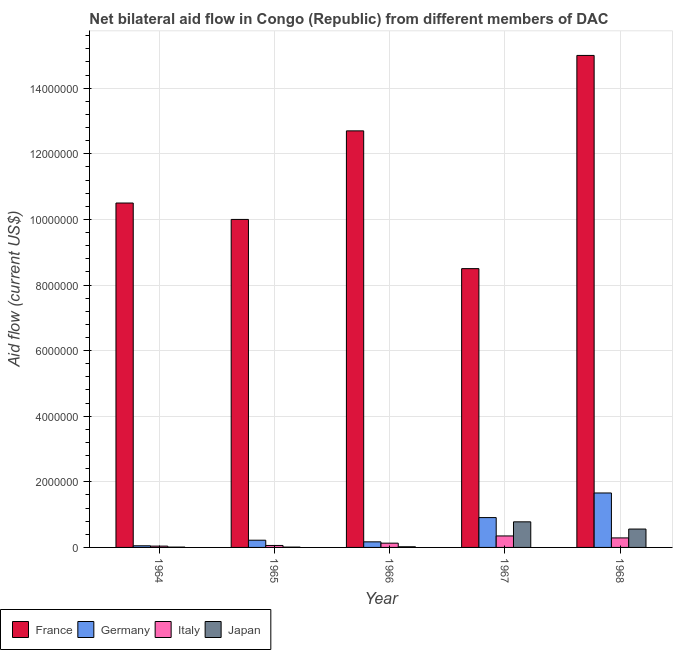How many different coloured bars are there?
Your answer should be compact. 4. Are the number of bars on each tick of the X-axis equal?
Offer a very short reply. Yes. How many bars are there on the 5th tick from the right?
Your response must be concise. 4. What is the label of the 4th group of bars from the left?
Your response must be concise. 1967. What is the amount of aid given by italy in 1965?
Your answer should be compact. 6.00e+04. Across all years, what is the maximum amount of aid given by france?
Your answer should be very brief. 1.50e+07. Across all years, what is the minimum amount of aid given by japan?
Your answer should be very brief. 10000. In which year was the amount of aid given by japan maximum?
Your answer should be compact. 1967. In which year was the amount of aid given by france minimum?
Offer a very short reply. 1967. What is the total amount of aid given by germany in the graph?
Ensure brevity in your answer.  3.01e+06. What is the difference between the amount of aid given by france in 1966 and that in 1968?
Make the answer very short. -2.30e+06. What is the difference between the amount of aid given by france in 1965 and the amount of aid given by japan in 1967?
Offer a terse response. 1.50e+06. What is the average amount of aid given by italy per year?
Provide a short and direct response. 1.74e+05. What is the ratio of the amount of aid given by japan in 1967 to that in 1968?
Your answer should be very brief. 1.39. Is the difference between the amount of aid given by japan in 1964 and 1968 greater than the difference between the amount of aid given by italy in 1964 and 1968?
Provide a short and direct response. No. What is the difference between the highest and the second highest amount of aid given by france?
Keep it short and to the point. 2.30e+06. What is the difference between the highest and the lowest amount of aid given by germany?
Provide a short and direct response. 1.61e+06. Is it the case that in every year, the sum of the amount of aid given by italy and amount of aid given by france is greater than the sum of amount of aid given by germany and amount of aid given by japan?
Provide a succinct answer. No. What does the 4th bar from the left in 1965 represents?
Give a very brief answer. Japan. What does the 3rd bar from the right in 1964 represents?
Offer a very short reply. Germany. Are all the bars in the graph horizontal?
Offer a terse response. No. How many years are there in the graph?
Your answer should be very brief. 5. Does the graph contain any zero values?
Provide a succinct answer. No. Where does the legend appear in the graph?
Provide a succinct answer. Bottom left. How many legend labels are there?
Give a very brief answer. 4. What is the title of the graph?
Your answer should be very brief. Net bilateral aid flow in Congo (Republic) from different members of DAC. What is the Aid flow (current US$) in France in 1964?
Your response must be concise. 1.05e+07. What is the Aid flow (current US$) of Germany in 1964?
Your response must be concise. 5.00e+04. What is the Aid flow (current US$) in Japan in 1964?
Offer a very short reply. 10000. What is the Aid flow (current US$) of Germany in 1965?
Ensure brevity in your answer.  2.20e+05. What is the Aid flow (current US$) of Italy in 1965?
Offer a very short reply. 6.00e+04. What is the Aid flow (current US$) in France in 1966?
Your response must be concise. 1.27e+07. What is the Aid flow (current US$) in Japan in 1966?
Ensure brevity in your answer.  2.00e+04. What is the Aid flow (current US$) of France in 1967?
Provide a succinct answer. 8.50e+06. What is the Aid flow (current US$) in Germany in 1967?
Your answer should be very brief. 9.10e+05. What is the Aid flow (current US$) of Japan in 1967?
Provide a short and direct response. 7.80e+05. What is the Aid flow (current US$) of France in 1968?
Keep it short and to the point. 1.50e+07. What is the Aid flow (current US$) in Germany in 1968?
Your answer should be compact. 1.66e+06. What is the Aid flow (current US$) in Italy in 1968?
Your response must be concise. 2.90e+05. What is the Aid flow (current US$) of Japan in 1968?
Make the answer very short. 5.60e+05. Across all years, what is the maximum Aid flow (current US$) of France?
Your answer should be very brief. 1.50e+07. Across all years, what is the maximum Aid flow (current US$) of Germany?
Offer a very short reply. 1.66e+06. Across all years, what is the maximum Aid flow (current US$) in Japan?
Ensure brevity in your answer.  7.80e+05. Across all years, what is the minimum Aid flow (current US$) in France?
Offer a terse response. 8.50e+06. Across all years, what is the minimum Aid flow (current US$) in Germany?
Provide a short and direct response. 5.00e+04. Across all years, what is the minimum Aid flow (current US$) in Italy?
Your answer should be compact. 4.00e+04. Across all years, what is the minimum Aid flow (current US$) in Japan?
Keep it short and to the point. 10000. What is the total Aid flow (current US$) of France in the graph?
Offer a very short reply. 5.67e+07. What is the total Aid flow (current US$) in Germany in the graph?
Your answer should be very brief. 3.01e+06. What is the total Aid flow (current US$) of Italy in the graph?
Offer a very short reply. 8.70e+05. What is the total Aid flow (current US$) of Japan in the graph?
Offer a very short reply. 1.38e+06. What is the difference between the Aid flow (current US$) in France in 1964 and that in 1966?
Give a very brief answer. -2.20e+06. What is the difference between the Aid flow (current US$) of Japan in 1964 and that in 1966?
Your response must be concise. -10000. What is the difference between the Aid flow (current US$) of France in 1964 and that in 1967?
Your response must be concise. 2.00e+06. What is the difference between the Aid flow (current US$) of Germany in 1964 and that in 1967?
Provide a succinct answer. -8.60e+05. What is the difference between the Aid flow (current US$) in Italy in 1964 and that in 1967?
Offer a very short reply. -3.10e+05. What is the difference between the Aid flow (current US$) of Japan in 1964 and that in 1967?
Offer a terse response. -7.70e+05. What is the difference between the Aid flow (current US$) of France in 1964 and that in 1968?
Your answer should be compact. -4.50e+06. What is the difference between the Aid flow (current US$) in Germany in 1964 and that in 1968?
Provide a short and direct response. -1.61e+06. What is the difference between the Aid flow (current US$) in Italy in 1964 and that in 1968?
Your answer should be very brief. -2.50e+05. What is the difference between the Aid flow (current US$) of Japan in 1964 and that in 1968?
Provide a short and direct response. -5.50e+05. What is the difference between the Aid flow (current US$) in France in 1965 and that in 1966?
Provide a succinct answer. -2.70e+06. What is the difference between the Aid flow (current US$) in Japan in 1965 and that in 1966?
Ensure brevity in your answer.  -10000. What is the difference between the Aid flow (current US$) in France in 1965 and that in 1967?
Offer a very short reply. 1.50e+06. What is the difference between the Aid flow (current US$) of Germany in 1965 and that in 1967?
Offer a terse response. -6.90e+05. What is the difference between the Aid flow (current US$) in Japan in 1965 and that in 1967?
Provide a succinct answer. -7.70e+05. What is the difference between the Aid flow (current US$) of France in 1965 and that in 1968?
Keep it short and to the point. -5.00e+06. What is the difference between the Aid flow (current US$) of Germany in 1965 and that in 1968?
Your response must be concise. -1.44e+06. What is the difference between the Aid flow (current US$) of Japan in 1965 and that in 1968?
Keep it short and to the point. -5.50e+05. What is the difference between the Aid flow (current US$) in France in 1966 and that in 1967?
Your answer should be compact. 4.20e+06. What is the difference between the Aid flow (current US$) in Germany in 1966 and that in 1967?
Ensure brevity in your answer.  -7.40e+05. What is the difference between the Aid flow (current US$) in Italy in 1966 and that in 1967?
Give a very brief answer. -2.20e+05. What is the difference between the Aid flow (current US$) of Japan in 1966 and that in 1967?
Your response must be concise. -7.60e+05. What is the difference between the Aid flow (current US$) in France in 1966 and that in 1968?
Offer a terse response. -2.30e+06. What is the difference between the Aid flow (current US$) of Germany in 1966 and that in 1968?
Provide a succinct answer. -1.49e+06. What is the difference between the Aid flow (current US$) of Japan in 1966 and that in 1968?
Your answer should be very brief. -5.40e+05. What is the difference between the Aid flow (current US$) in France in 1967 and that in 1968?
Offer a terse response. -6.50e+06. What is the difference between the Aid flow (current US$) in Germany in 1967 and that in 1968?
Provide a succinct answer. -7.50e+05. What is the difference between the Aid flow (current US$) in Japan in 1967 and that in 1968?
Offer a terse response. 2.20e+05. What is the difference between the Aid flow (current US$) in France in 1964 and the Aid flow (current US$) in Germany in 1965?
Offer a very short reply. 1.03e+07. What is the difference between the Aid flow (current US$) of France in 1964 and the Aid flow (current US$) of Italy in 1965?
Ensure brevity in your answer.  1.04e+07. What is the difference between the Aid flow (current US$) in France in 1964 and the Aid flow (current US$) in Japan in 1965?
Give a very brief answer. 1.05e+07. What is the difference between the Aid flow (current US$) in Germany in 1964 and the Aid flow (current US$) in Italy in 1965?
Offer a terse response. -10000. What is the difference between the Aid flow (current US$) in Germany in 1964 and the Aid flow (current US$) in Japan in 1965?
Provide a short and direct response. 4.00e+04. What is the difference between the Aid flow (current US$) in Italy in 1964 and the Aid flow (current US$) in Japan in 1965?
Give a very brief answer. 3.00e+04. What is the difference between the Aid flow (current US$) of France in 1964 and the Aid flow (current US$) of Germany in 1966?
Keep it short and to the point. 1.03e+07. What is the difference between the Aid flow (current US$) in France in 1964 and the Aid flow (current US$) in Italy in 1966?
Ensure brevity in your answer.  1.04e+07. What is the difference between the Aid flow (current US$) of France in 1964 and the Aid flow (current US$) of Japan in 1966?
Offer a very short reply. 1.05e+07. What is the difference between the Aid flow (current US$) of Germany in 1964 and the Aid flow (current US$) of Japan in 1966?
Offer a terse response. 3.00e+04. What is the difference between the Aid flow (current US$) in France in 1964 and the Aid flow (current US$) in Germany in 1967?
Give a very brief answer. 9.59e+06. What is the difference between the Aid flow (current US$) in France in 1964 and the Aid flow (current US$) in Italy in 1967?
Offer a very short reply. 1.02e+07. What is the difference between the Aid flow (current US$) of France in 1964 and the Aid flow (current US$) of Japan in 1967?
Make the answer very short. 9.72e+06. What is the difference between the Aid flow (current US$) of Germany in 1964 and the Aid flow (current US$) of Japan in 1967?
Offer a very short reply. -7.30e+05. What is the difference between the Aid flow (current US$) of Italy in 1964 and the Aid flow (current US$) of Japan in 1967?
Offer a terse response. -7.40e+05. What is the difference between the Aid flow (current US$) of France in 1964 and the Aid flow (current US$) of Germany in 1968?
Give a very brief answer. 8.84e+06. What is the difference between the Aid flow (current US$) in France in 1964 and the Aid flow (current US$) in Italy in 1968?
Your answer should be very brief. 1.02e+07. What is the difference between the Aid flow (current US$) of France in 1964 and the Aid flow (current US$) of Japan in 1968?
Provide a succinct answer. 9.94e+06. What is the difference between the Aid flow (current US$) in Germany in 1964 and the Aid flow (current US$) in Italy in 1968?
Ensure brevity in your answer.  -2.40e+05. What is the difference between the Aid flow (current US$) of Germany in 1964 and the Aid flow (current US$) of Japan in 1968?
Make the answer very short. -5.10e+05. What is the difference between the Aid flow (current US$) of Italy in 1964 and the Aid flow (current US$) of Japan in 1968?
Your answer should be very brief. -5.20e+05. What is the difference between the Aid flow (current US$) of France in 1965 and the Aid flow (current US$) of Germany in 1966?
Provide a short and direct response. 9.83e+06. What is the difference between the Aid flow (current US$) in France in 1965 and the Aid flow (current US$) in Italy in 1966?
Offer a very short reply. 9.87e+06. What is the difference between the Aid flow (current US$) of France in 1965 and the Aid flow (current US$) of Japan in 1966?
Keep it short and to the point. 9.98e+06. What is the difference between the Aid flow (current US$) in Germany in 1965 and the Aid flow (current US$) in Japan in 1966?
Provide a succinct answer. 2.00e+05. What is the difference between the Aid flow (current US$) in Italy in 1965 and the Aid flow (current US$) in Japan in 1966?
Ensure brevity in your answer.  4.00e+04. What is the difference between the Aid flow (current US$) in France in 1965 and the Aid flow (current US$) in Germany in 1967?
Give a very brief answer. 9.09e+06. What is the difference between the Aid flow (current US$) in France in 1965 and the Aid flow (current US$) in Italy in 1967?
Offer a very short reply. 9.65e+06. What is the difference between the Aid flow (current US$) in France in 1965 and the Aid flow (current US$) in Japan in 1967?
Offer a very short reply. 9.22e+06. What is the difference between the Aid flow (current US$) of Germany in 1965 and the Aid flow (current US$) of Italy in 1967?
Offer a terse response. -1.30e+05. What is the difference between the Aid flow (current US$) of Germany in 1965 and the Aid flow (current US$) of Japan in 1967?
Your response must be concise. -5.60e+05. What is the difference between the Aid flow (current US$) in Italy in 1965 and the Aid flow (current US$) in Japan in 1967?
Give a very brief answer. -7.20e+05. What is the difference between the Aid flow (current US$) of France in 1965 and the Aid flow (current US$) of Germany in 1968?
Offer a very short reply. 8.34e+06. What is the difference between the Aid flow (current US$) in France in 1965 and the Aid flow (current US$) in Italy in 1968?
Provide a succinct answer. 9.71e+06. What is the difference between the Aid flow (current US$) of France in 1965 and the Aid flow (current US$) of Japan in 1968?
Ensure brevity in your answer.  9.44e+06. What is the difference between the Aid flow (current US$) in Germany in 1965 and the Aid flow (current US$) in Italy in 1968?
Provide a succinct answer. -7.00e+04. What is the difference between the Aid flow (current US$) in Germany in 1965 and the Aid flow (current US$) in Japan in 1968?
Your response must be concise. -3.40e+05. What is the difference between the Aid flow (current US$) in Italy in 1965 and the Aid flow (current US$) in Japan in 1968?
Ensure brevity in your answer.  -5.00e+05. What is the difference between the Aid flow (current US$) in France in 1966 and the Aid flow (current US$) in Germany in 1967?
Your answer should be very brief. 1.18e+07. What is the difference between the Aid flow (current US$) in France in 1966 and the Aid flow (current US$) in Italy in 1967?
Your answer should be compact. 1.24e+07. What is the difference between the Aid flow (current US$) in France in 1966 and the Aid flow (current US$) in Japan in 1967?
Your answer should be very brief. 1.19e+07. What is the difference between the Aid flow (current US$) of Germany in 1966 and the Aid flow (current US$) of Japan in 1967?
Make the answer very short. -6.10e+05. What is the difference between the Aid flow (current US$) in Italy in 1966 and the Aid flow (current US$) in Japan in 1967?
Your answer should be very brief. -6.50e+05. What is the difference between the Aid flow (current US$) in France in 1966 and the Aid flow (current US$) in Germany in 1968?
Offer a terse response. 1.10e+07. What is the difference between the Aid flow (current US$) of France in 1966 and the Aid flow (current US$) of Italy in 1968?
Your answer should be compact. 1.24e+07. What is the difference between the Aid flow (current US$) of France in 1966 and the Aid flow (current US$) of Japan in 1968?
Make the answer very short. 1.21e+07. What is the difference between the Aid flow (current US$) in Germany in 1966 and the Aid flow (current US$) in Italy in 1968?
Provide a succinct answer. -1.20e+05. What is the difference between the Aid flow (current US$) of Germany in 1966 and the Aid flow (current US$) of Japan in 1968?
Keep it short and to the point. -3.90e+05. What is the difference between the Aid flow (current US$) of Italy in 1966 and the Aid flow (current US$) of Japan in 1968?
Offer a very short reply. -4.30e+05. What is the difference between the Aid flow (current US$) in France in 1967 and the Aid flow (current US$) in Germany in 1968?
Provide a short and direct response. 6.84e+06. What is the difference between the Aid flow (current US$) of France in 1967 and the Aid flow (current US$) of Italy in 1968?
Your answer should be compact. 8.21e+06. What is the difference between the Aid flow (current US$) of France in 1967 and the Aid flow (current US$) of Japan in 1968?
Your answer should be very brief. 7.94e+06. What is the difference between the Aid flow (current US$) in Germany in 1967 and the Aid flow (current US$) in Italy in 1968?
Give a very brief answer. 6.20e+05. What is the average Aid flow (current US$) of France per year?
Your answer should be compact. 1.13e+07. What is the average Aid flow (current US$) of Germany per year?
Your answer should be compact. 6.02e+05. What is the average Aid flow (current US$) in Italy per year?
Make the answer very short. 1.74e+05. What is the average Aid flow (current US$) in Japan per year?
Provide a succinct answer. 2.76e+05. In the year 1964, what is the difference between the Aid flow (current US$) in France and Aid flow (current US$) in Germany?
Ensure brevity in your answer.  1.04e+07. In the year 1964, what is the difference between the Aid flow (current US$) of France and Aid flow (current US$) of Italy?
Keep it short and to the point. 1.05e+07. In the year 1964, what is the difference between the Aid flow (current US$) in France and Aid flow (current US$) in Japan?
Offer a very short reply. 1.05e+07. In the year 1965, what is the difference between the Aid flow (current US$) in France and Aid flow (current US$) in Germany?
Keep it short and to the point. 9.78e+06. In the year 1965, what is the difference between the Aid flow (current US$) of France and Aid flow (current US$) of Italy?
Your response must be concise. 9.94e+06. In the year 1965, what is the difference between the Aid flow (current US$) in France and Aid flow (current US$) in Japan?
Give a very brief answer. 9.99e+06. In the year 1966, what is the difference between the Aid flow (current US$) in France and Aid flow (current US$) in Germany?
Offer a very short reply. 1.25e+07. In the year 1966, what is the difference between the Aid flow (current US$) of France and Aid flow (current US$) of Italy?
Provide a succinct answer. 1.26e+07. In the year 1966, what is the difference between the Aid flow (current US$) in France and Aid flow (current US$) in Japan?
Give a very brief answer. 1.27e+07. In the year 1966, what is the difference between the Aid flow (current US$) of Germany and Aid flow (current US$) of Japan?
Your answer should be compact. 1.50e+05. In the year 1967, what is the difference between the Aid flow (current US$) of France and Aid flow (current US$) of Germany?
Make the answer very short. 7.59e+06. In the year 1967, what is the difference between the Aid flow (current US$) in France and Aid flow (current US$) in Italy?
Provide a short and direct response. 8.15e+06. In the year 1967, what is the difference between the Aid flow (current US$) of France and Aid flow (current US$) of Japan?
Provide a short and direct response. 7.72e+06. In the year 1967, what is the difference between the Aid flow (current US$) of Germany and Aid flow (current US$) of Italy?
Provide a short and direct response. 5.60e+05. In the year 1967, what is the difference between the Aid flow (current US$) of Germany and Aid flow (current US$) of Japan?
Your answer should be compact. 1.30e+05. In the year 1967, what is the difference between the Aid flow (current US$) of Italy and Aid flow (current US$) of Japan?
Your answer should be compact. -4.30e+05. In the year 1968, what is the difference between the Aid flow (current US$) in France and Aid flow (current US$) in Germany?
Offer a very short reply. 1.33e+07. In the year 1968, what is the difference between the Aid flow (current US$) in France and Aid flow (current US$) in Italy?
Your answer should be very brief. 1.47e+07. In the year 1968, what is the difference between the Aid flow (current US$) in France and Aid flow (current US$) in Japan?
Your answer should be very brief. 1.44e+07. In the year 1968, what is the difference between the Aid flow (current US$) in Germany and Aid flow (current US$) in Italy?
Ensure brevity in your answer.  1.37e+06. In the year 1968, what is the difference between the Aid flow (current US$) of Germany and Aid flow (current US$) of Japan?
Give a very brief answer. 1.10e+06. In the year 1968, what is the difference between the Aid flow (current US$) of Italy and Aid flow (current US$) of Japan?
Your answer should be very brief. -2.70e+05. What is the ratio of the Aid flow (current US$) in France in 1964 to that in 1965?
Offer a terse response. 1.05. What is the ratio of the Aid flow (current US$) in Germany in 1964 to that in 1965?
Ensure brevity in your answer.  0.23. What is the ratio of the Aid flow (current US$) in Italy in 1964 to that in 1965?
Provide a short and direct response. 0.67. What is the ratio of the Aid flow (current US$) in France in 1964 to that in 1966?
Make the answer very short. 0.83. What is the ratio of the Aid flow (current US$) of Germany in 1964 to that in 1966?
Provide a succinct answer. 0.29. What is the ratio of the Aid flow (current US$) in Italy in 1964 to that in 1966?
Keep it short and to the point. 0.31. What is the ratio of the Aid flow (current US$) in France in 1964 to that in 1967?
Make the answer very short. 1.24. What is the ratio of the Aid flow (current US$) of Germany in 1964 to that in 1967?
Your answer should be very brief. 0.05. What is the ratio of the Aid flow (current US$) of Italy in 1964 to that in 1967?
Your answer should be compact. 0.11. What is the ratio of the Aid flow (current US$) of Japan in 1964 to that in 1967?
Give a very brief answer. 0.01. What is the ratio of the Aid flow (current US$) of Germany in 1964 to that in 1968?
Ensure brevity in your answer.  0.03. What is the ratio of the Aid flow (current US$) in Italy in 1964 to that in 1968?
Provide a short and direct response. 0.14. What is the ratio of the Aid flow (current US$) of Japan in 1964 to that in 1968?
Keep it short and to the point. 0.02. What is the ratio of the Aid flow (current US$) in France in 1965 to that in 1966?
Offer a terse response. 0.79. What is the ratio of the Aid flow (current US$) of Germany in 1965 to that in 1966?
Provide a short and direct response. 1.29. What is the ratio of the Aid flow (current US$) of Italy in 1965 to that in 1966?
Your response must be concise. 0.46. What is the ratio of the Aid flow (current US$) in France in 1965 to that in 1967?
Your answer should be very brief. 1.18. What is the ratio of the Aid flow (current US$) of Germany in 1965 to that in 1967?
Your answer should be very brief. 0.24. What is the ratio of the Aid flow (current US$) in Italy in 1965 to that in 1967?
Keep it short and to the point. 0.17. What is the ratio of the Aid flow (current US$) of Japan in 1965 to that in 1967?
Keep it short and to the point. 0.01. What is the ratio of the Aid flow (current US$) of France in 1965 to that in 1968?
Make the answer very short. 0.67. What is the ratio of the Aid flow (current US$) in Germany in 1965 to that in 1968?
Your answer should be compact. 0.13. What is the ratio of the Aid flow (current US$) in Italy in 1965 to that in 1968?
Offer a terse response. 0.21. What is the ratio of the Aid flow (current US$) in Japan in 1965 to that in 1968?
Provide a short and direct response. 0.02. What is the ratio of the Aid flow (current US$) of France in 1966 to that in 1967?
Provide a short and direct response. 1.49. What is the ratio of the Aid flow (current US$) in Germany in 1966 to that in 1967?
Give a very brief answer. 0.19. What is the ratio of the Aid flow (current US$) in Italy in 1966 to that in 1967?
Your response must be concise. 0.37. What is the ratio of the Aid flow (current US$) of Japan in 1966 to that in 1967?
Make the answer very short. 0.03. What is the ratio of the Aid flow (current US$) of France in 1966 to that in 1968?
Ensure brevity in your answer.  0.85. What is the ratio of the Aid flow (current US$) in Germany in 1966 to that in 1968?
Provide a succinct answer. 0.1. What is the ratio of the Aid flow (current US$) of Italy in 1966 to that in 1968?
Your answer should be compact. 0.45. What is the ratio of the Aid flow (current US$) of Japan in 1966 to that in 1968?
Provide a short and direct response. 0.04. What is the ratio of the Aid flow (current US$) of France in 1967 to that in 1968?
Make the answer very short. 0.57. What is the ratio of the Aid flow (current US$) of Germany in 1967 to that in 1968?
Your response must be concise. 0.55. What is the ratio of the Aid flow (current US$) in Italy in 1967 to that in 1968?
Offer a very short reply. 1.21. What is the ratio of the Aid flow (current US$) of Japan in 1967 to that in 1968?
Offer a terse response. 1.39. What is the difference between the highest and the second highest Aid flow (current US$) of France?
Give a very brief answer. 2.30e+06. What is the difference between the highest and the second highest Aid flow (current US$) in Germany?
Provide a short and direct response. 7.50e+05. What is the difference between the highest and the lowest Aid flow (current US$) in France?
Give a very brief answer. 6.50e+06. What is the difference between the highest and the lowest Aid flow (current US$) of Germany?
Offer a terse response. 1.61e+06. What is the difference between the highest and the lowest Aid flow (current US$) in Japan?
Offer a terse response. 7.70e+05. 